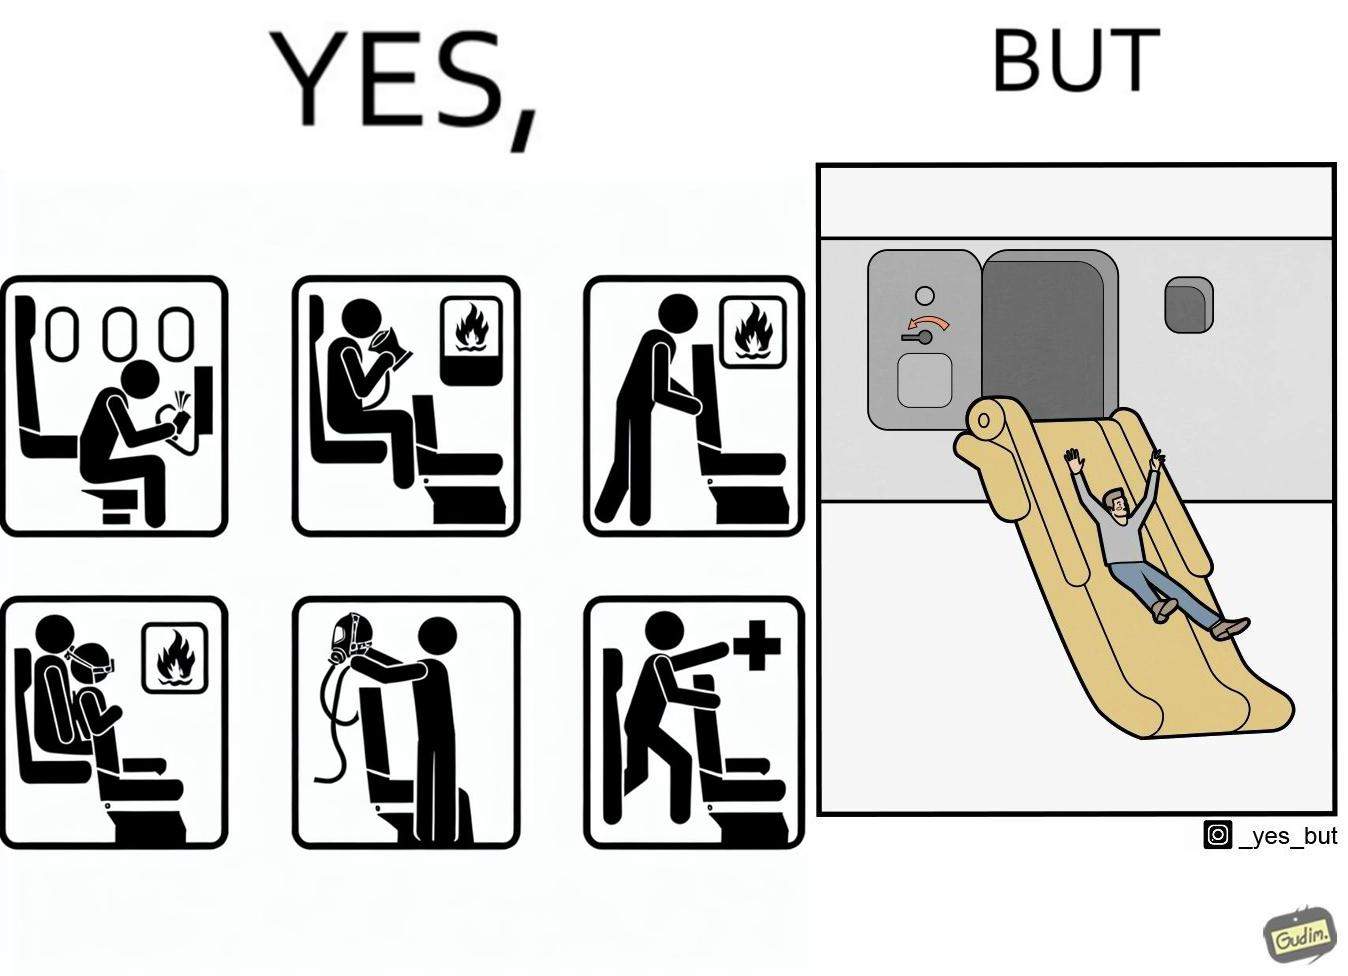What do you see in each half of this image? In the left part of the image: They are images of what one should do in an airplane in case of an imminent collision and fire In the right part of the image: It shows a man jumping out of an airplane in case of an emergency and using the emergency inflatable slides 